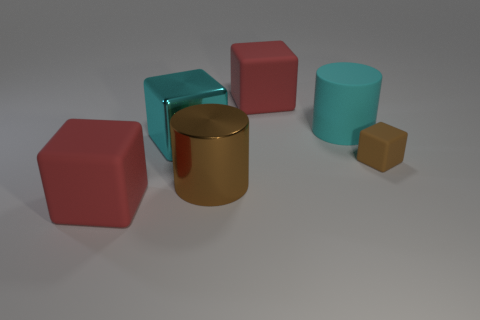Subtract all brown rubber cubes. How many cubes are left? 3 Add 1 brown rubber objects. How many objects exist? 7 Subtract all cyan blocks. How many blocks are left? 3 Add 3 big gray metallic balls. How many big gray metallic balls exist? 3 Subtract 0 green cubes. How many objects are left? 6 Subtract all cubes. How many objects are left? 2 Subtract 2 blocks. How many blocks are left? 2 Subtract all red cylinders. Subtract all purple spheres. How many cylinders are left? 2 Subtract all red balls. How many cyan cylinders are left? 1 Subtract all matte objects. Subtract all brown blocks. How many objects are left? 1 